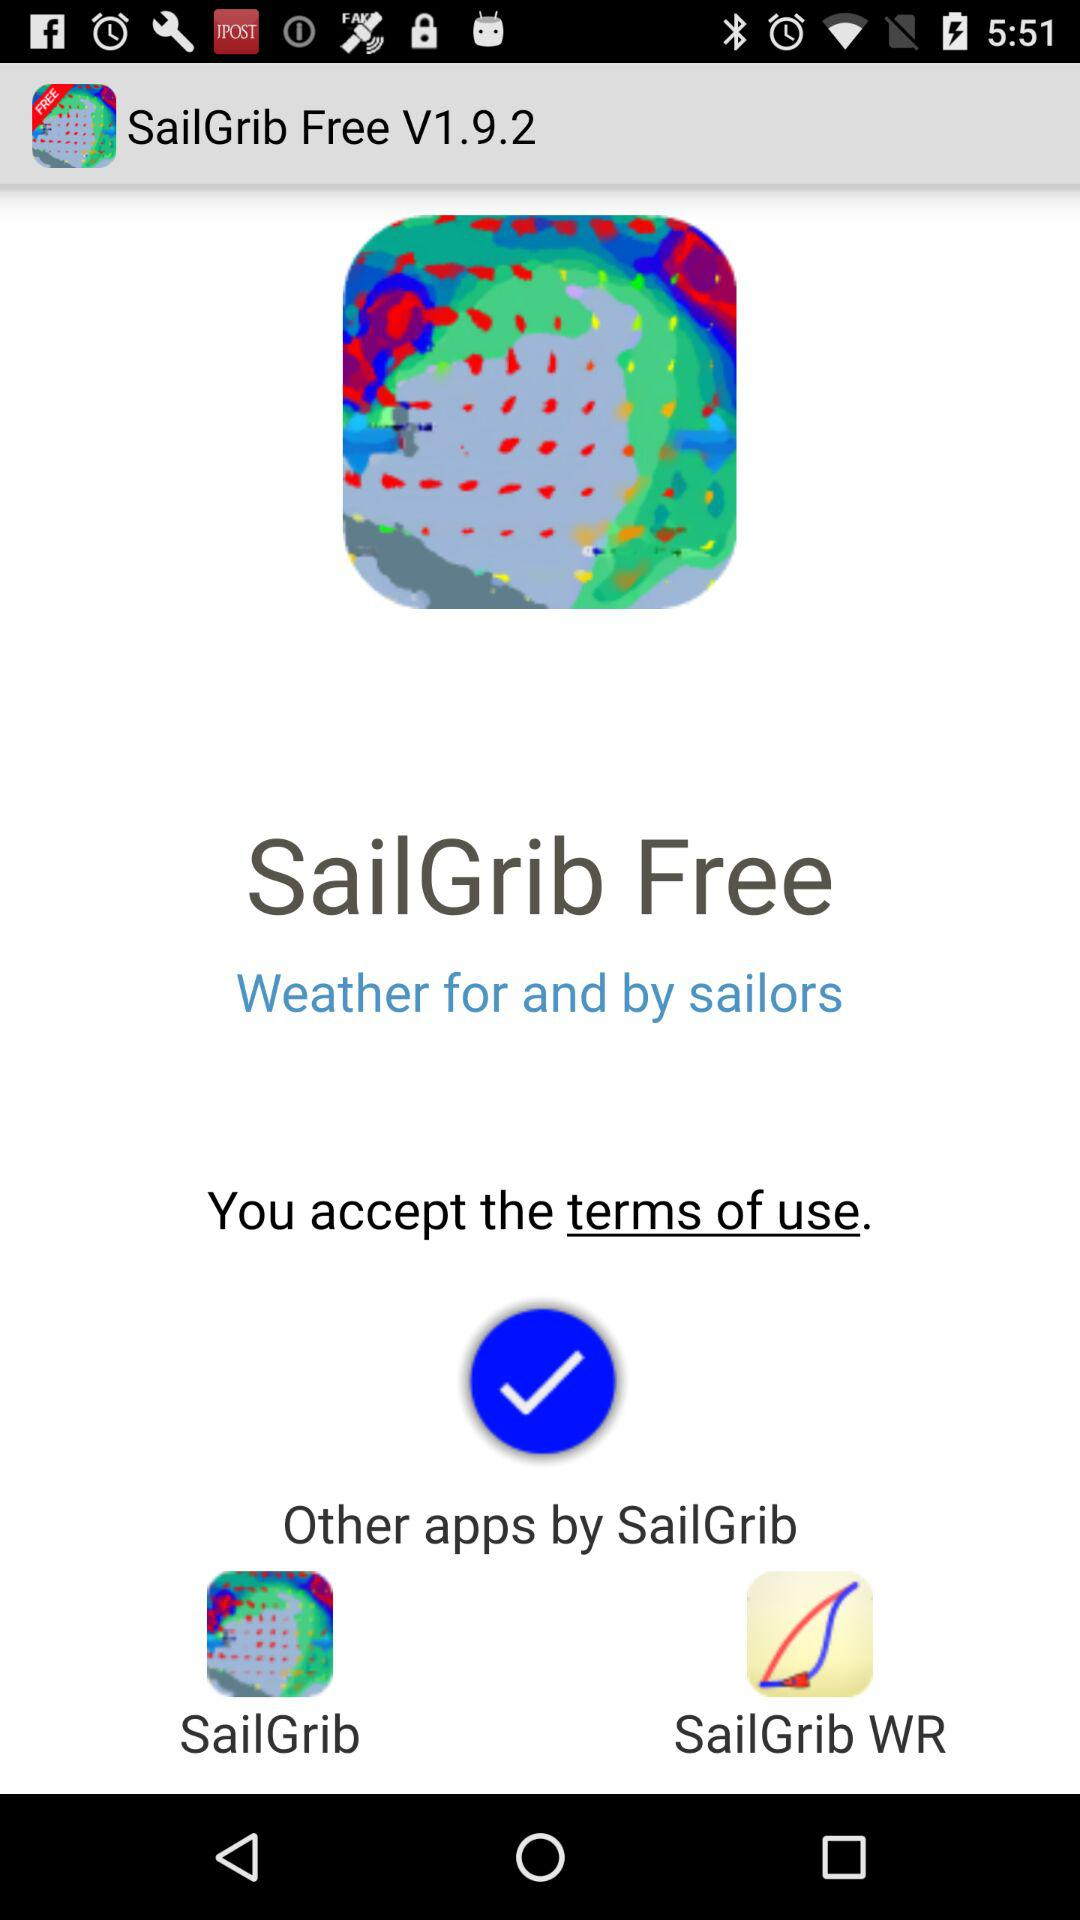What is the version number? The version number is 1.9.2. 